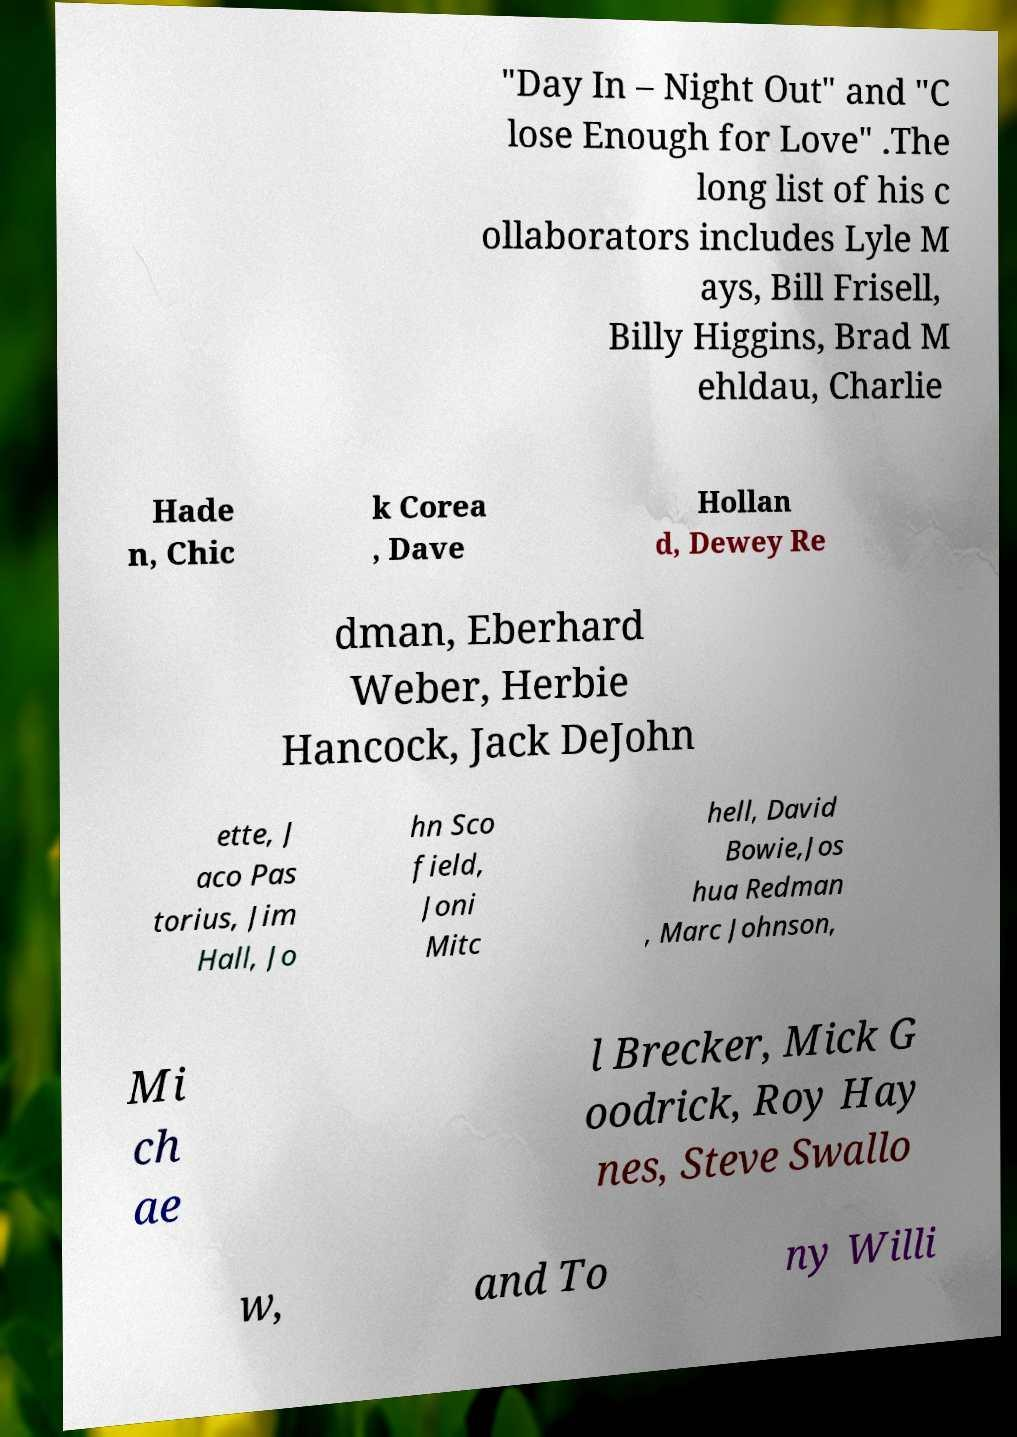Could you assist in decoding the text presented in this image and type it out clearly? "Day In – Night Out" and "C lose Enough for Love" .The long list of his c ollaborators includes Lyle M ays, Bill Frisell, Billy Higgins, Brad M ehldau, Charlie Hade n, Chic k Corea , Dave Hollan d, Dewey Re dman, Eberhard Weber, Herbie Hancock, Jack DeJohn ette, J aco Pas torius, Jim Hall, Jo hn Sco field, Joni Mitc hell, David Bowie,Jos hua Redman , Marc Johnson, Mi ch ae l Brecker, Mick G oodrick, Roy Hay nes, Steve Swallo w, and To ny Willi 